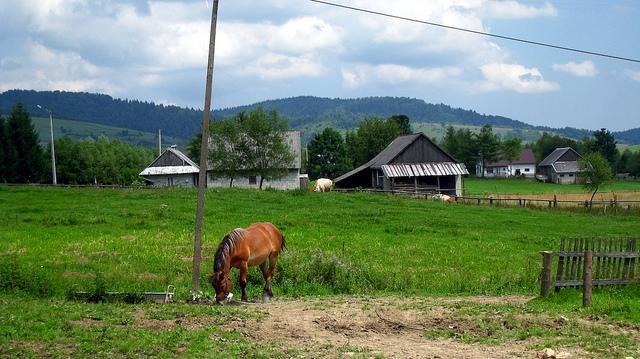How many horses are on the picture?
Give a very brief answer. 1. How many horses are there?
Give a very brief answer. 1. How many horses are in the picture?
Give a very brief answer. 1. How many people are wearing hat?
Give a very brief answer. 0. 